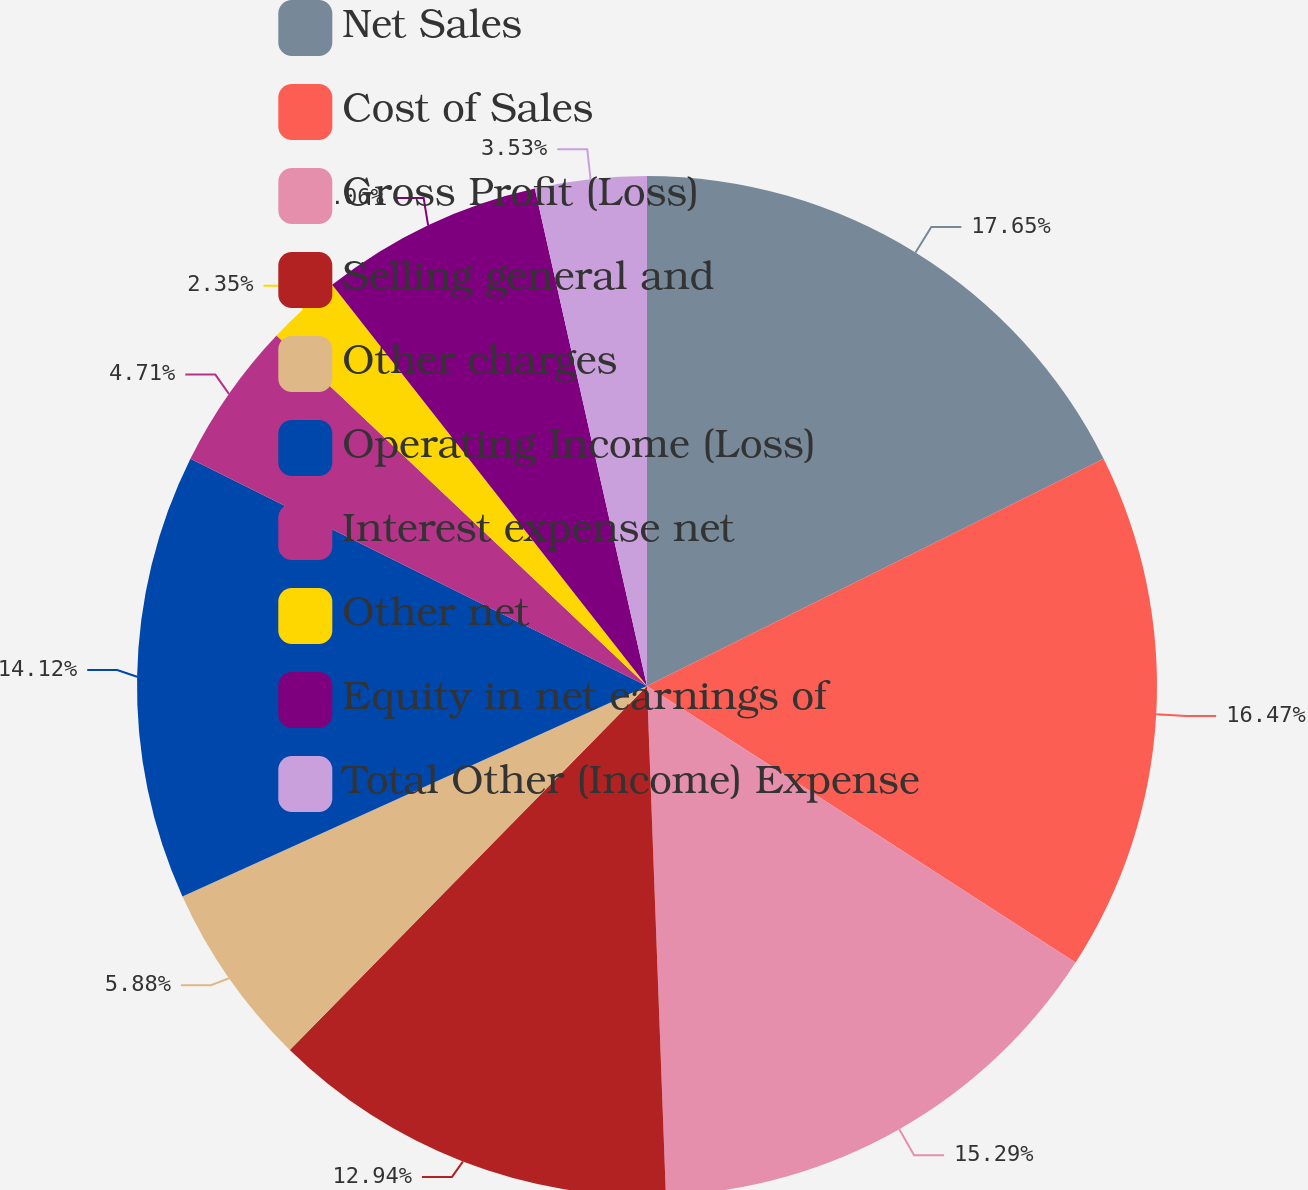Convert chart to OTSL. <chart><loc_0><loc_0><loc_500><loc_500><pie_chart><fcel>Net Sales<fcel>Cost of Sales<fcel>Gross Profit (Loss)<fcel>Selling general and<fcel>Other charges<fcel>Operating Income (Loss)<fcel>Interest expense net<fcel>Other net<fcel>Equity in net earnings of<fcel>Total Other (Income) Expense<nl><fcel>17.65%<fcel>16.47%<fcel>15.29%<fcel>12.94%<fcel>5.88%<fcel>14.12%<fcel>4.71%<fcel>2.35%<fcel>7.06%<fcel>3.53%<nl></chart> 